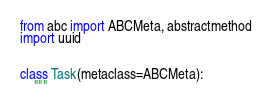<code> <loc_0><loc_0><loc_500><loc_500><_Python_>from abc import ABCMeta, abstractmethod
import uuid


class Task(metaclass=ABCMeta):
    """</code> 